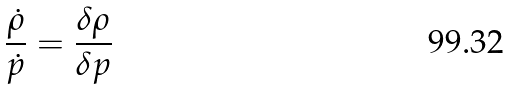<formula> <loc_0><loc_0><loc_500><loc_500>\frac { \dot { \rho } } { \dot { p } } = \frac { \delta \rho } { \delta p }</formula> 